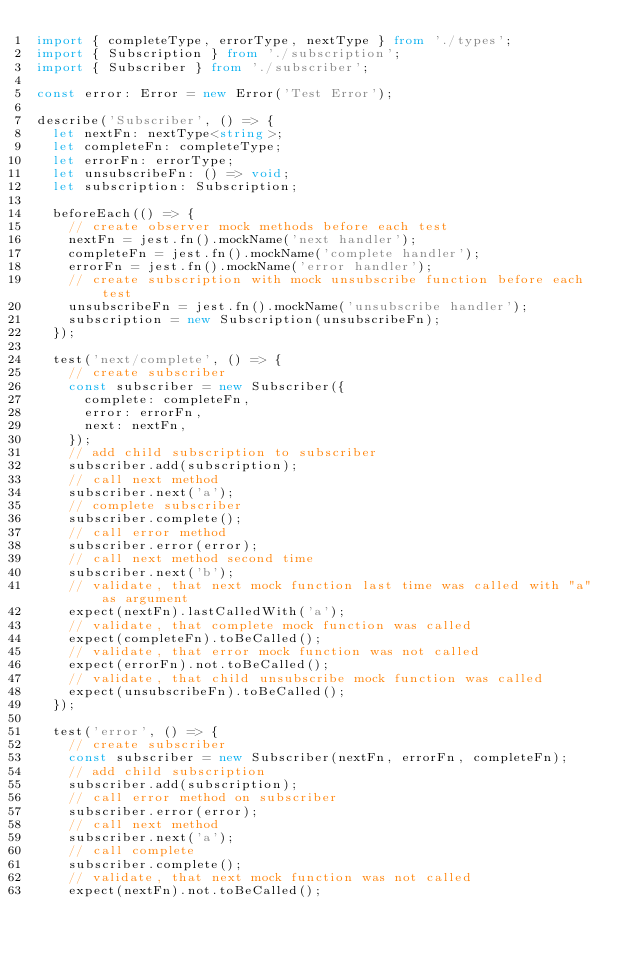<code> <loc_0><loc_0><loc_500><loc_500><_TypeScript_>import { completeType, errorType, nextType } from './types';
import { Subscription } from './subscription';
import { Subscriber } from './subscriber';

const error: Error = new Error('Test Error');

describe('Subscriber', () => {
  let nextFn: nextType<string>;
  let completeFn: completeType;
  let errorFn: errorType;
  let unsubscribeFn: () => void;
  let subscription: Subscription;

  beforeEach(() => {
    // create observer mock methods before each test
    nextFn = jest.fn().mockName('next handler');
    completeFn = jest.fn().mockName('complete handler');
    errorFn = jest.fn().mockName('error handler');
    // create subscription with mock unsubscribe function before each test
    unsubscribeFn = jest.fn().mockName('unsubscribe handler');
    subscription = new Subscription(unsubscribeFn);
  });

  test('next/complete', () => {
    // create subscriber
    const subscriber = new Subscriber({
      complete: completeFn,
      error: errorFn,
      next: nextFn,
    });
    // add child subscription to subscriber
    subscriber.add(subscription);
    // call next method
    subscriber.next('a');
    // complete subscriber
    subscriber.complete();
    // call error method
    subscriber.error(error);
    // call next method second time
    subscriber.next('b');
    // validate, that next mock function last time was called with "a" as argument
    expect(nextFn).lastCalledWith('a');
    // validate, that complete mock function was called
    expect(completeFn).toBeCalled();
    // validate, that error mock function was not called
    expect(errorFn).not.toBeCalled();
    // validate, that child unsubscribe mock function was called
    expect(unsubscribeFn).toBeCalled();
  });

  test('error', () => {
    // create subscriber
    const subscriber = new Subscriber(nextFn, errorFn, completeFn);
    // add child subscription
    subscriber.add(subscription);
    // call error method on subscriber
    subscriber.error(error);
    // call next method
    subscriber.next('a');
    // call complete
    subscriber.complete();
    // validate, that next mock function was not called
    expect(nextFn).not.toBeCalled();</code> 